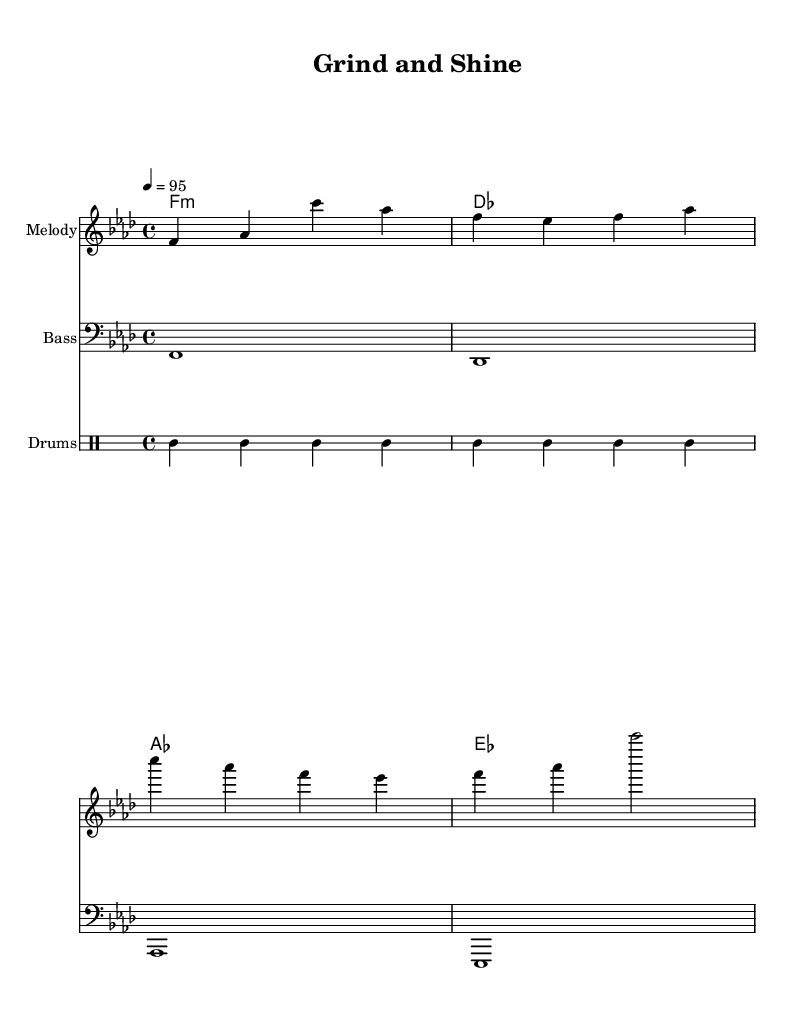What is the key signature of this music? The key signature indicated in the global section is 'f minor', which is shown by the presence of four flats (B♭, E♭, A♭, D♭).
Answer: F minor What is the time signature of this piece? The time signature is listed as '4/4', denoting that there are four beats per measure and the quarter note gets one beat.
Answer: 4/4 What is the tempo marking? The tempo indication in this score is '4 = 95', which signifies that a quarter note gets 95 beats per minute.
Answer: 95 What is the primary theme or message of the lyrics? The lyrics convey the message of motivation and hard work, emphasizing the importance of rising up and putting in effort to achieve goals.
Answer: Motivation How many different instruments are specified in this score? The score includes three different instruments: Melody, Bass, and Drums, comprising the main components of a typical hip-hop track.
Answer: Three What type of musical form is suggested by the repeated phrases in the melody? The repetition of certain melodic phrases and structured lyrics denotes a verse-chorus form, typical in motivational hip-hop, emphasizing key messages through repetition.
Answer: Verse-chorus 